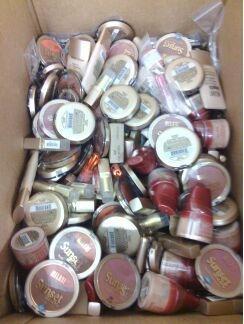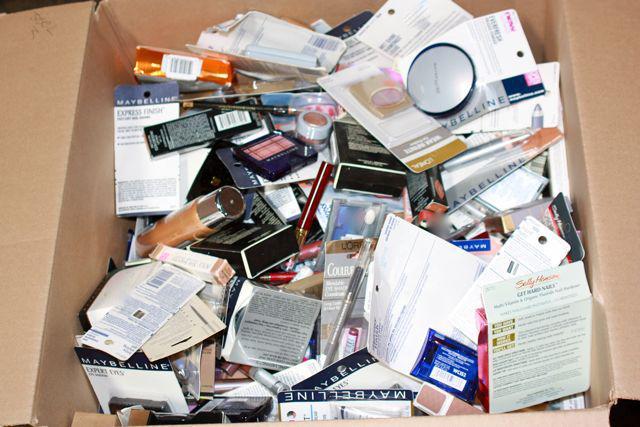The first image is the image on the left, the second image is the image on the right. Examine the images to the left and right. Is the description "The left image includes at least one round glass fragrance bottle but does not include any boxes." accurate? Answer yes or no. No. The first image is the image on the left, the second image is the image on the right. For the images shown, is this caption "In the image on the right, perfumes are stacked in front of a bag." true? Answer yes or no. No. 